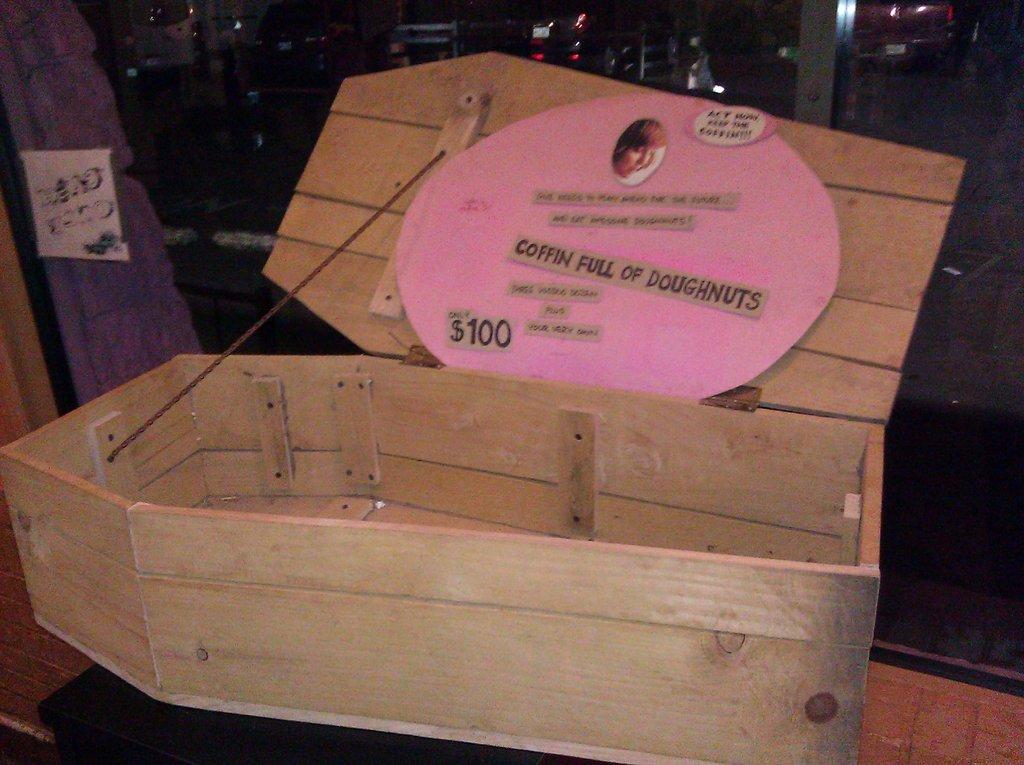What's the value shown?
Your answer should be very brief. $100. What is this a coffin for?
Your answer should be compact. Doughnuts. 